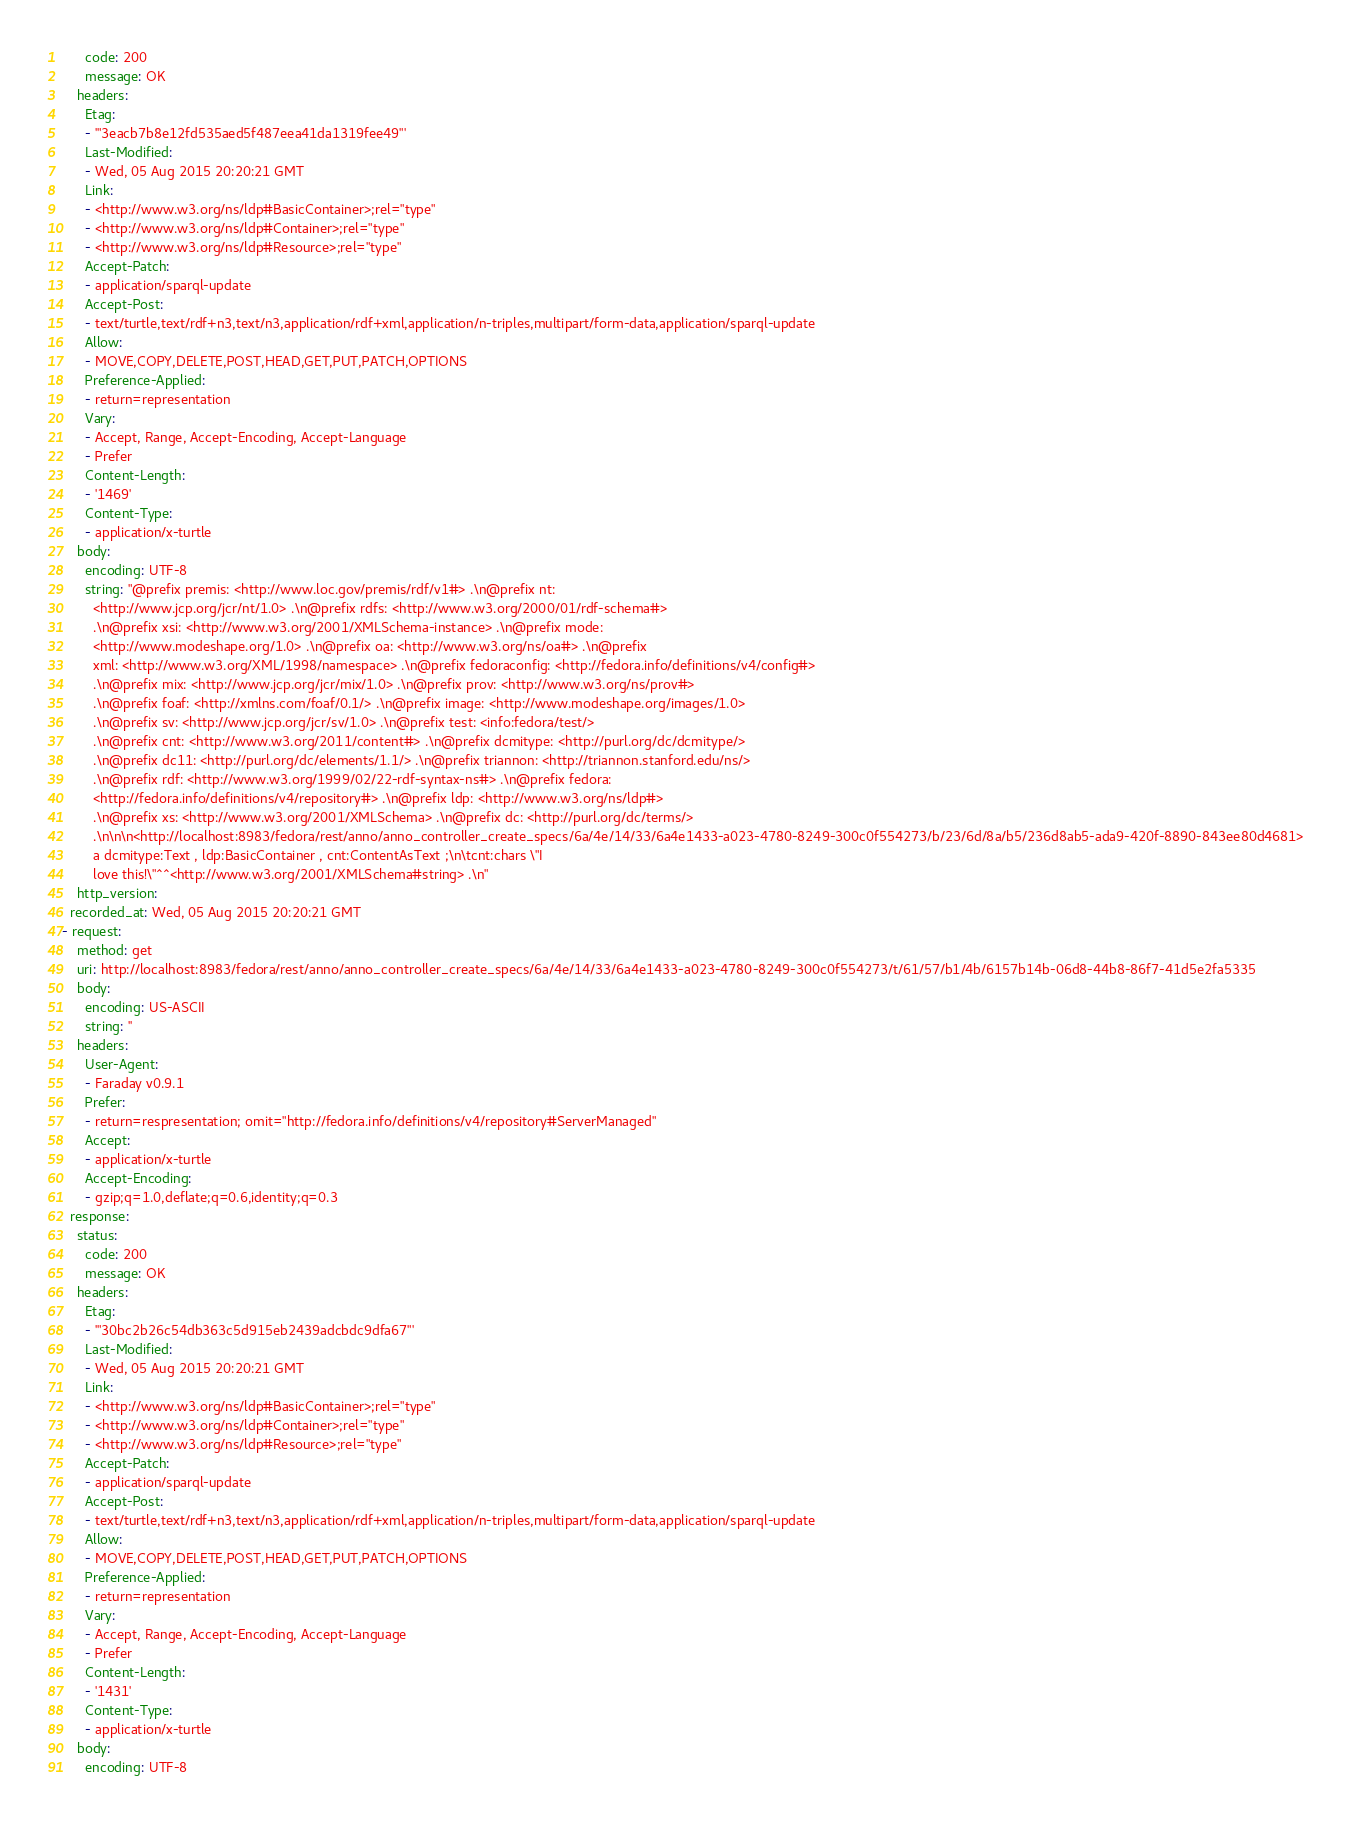Convert code to text. <code><loc_0><loc_0><loc_500><loc_500><_YAML_>      code: 200
      message: OK
    headers:
      Etag:
      - '"3eacb7b8e12fd535aed5f487eea41da1319fee49"'
      Last-Modified:
      - Wed, 05 Aug 2015 20:20:21 GMT
      Link:
      - <http://www.w3.org/ns/ldp#BasicContainer>;rel="type"
      - <http://www.w3.org/ns/ldp#Container>;rel="type"
      - <http://www.w3.org/ns/ldp#Resource>;rel="type"
      Accept-Patch:
      - application/sparql-update
      Accept-Post:
      - text/turtle,text/rdf+n3,text/n3,application/rdf+xml,application/n-triples,multipart/form-data,application/sparql-update
      Allow:
      - MOVE,COPY,DELETE,POST,HEAD,GET,PUT,PATCH,OPTIONS
      Preference-Applied:
      - return=representation
      Vary:
      - Accept, Range, Accept-Encoding, Accept-Language
      - Prefer
      Content-Length:
      - '1469'
      Content-Type:
      - application/x-turtle
    body:
      encoding: UTF-8
      string: "@prefix premis: <http://www.loc.gov/premis/rdf/v1#> .\n@prefix nt:
        <http://www.jcp.org/jcr/nt/1.0> .\n@prefix rdfs: <http://www.w3.org/2000/01/rdf-schema#>
        .\n@prefix xsi: <http://www.w3.org/2001/XMLSchema-instance> .\n@prefix mode:
        <http://www.modeshape.org/1.0> .\n@prefix oa: <http://www.w3.org/ns/oa#> .\n@prefix
        xml: <http://www.w3.org/XML/1998/namespace> .\n@prefix fedoraconfig: <http://fedora.info/definitions/v4/config#>
        .\n@prefix mix: <http://www.jcp.org/jcr/mix/1.0> .\n@prefix prov: <http://www.w3.org/ns/prov#>
        .\n@prefix foaf: <http://xmlns.com/foaf/0.1/> .\n@prefix image: <http://www.modeshape.org/images/1.0>
        .\n@prefix sv: <http://www.jcp.org/jcr/sv/1.0> .\n@prefix test: <info:fedora/test/>
        .\n@prefix cnt: <http://www.w3.org/2011/content#> .\n@prefix dcmitype: <http://purl.org/dc/dcmitype/>
        .\n@prefix dc11: <http://purl.org/dc/elements/1.1/> .\n@prefix triannon: <http://triannon.stanford.edu/ns/>
        .\n@prefix rdf: <http://www.w3.org/1999/02/22-rdf-syntax-ns#> .\n@prefix fedora:
        <http://fedora.info/definitions/v4/repository#> .\n@prefix ldp: <http://www.w3.org/ns/ldp#>
        .\n@prefix xs: <http://www.w3.org/2001/XMLSchema> .\n@prefix dc: <http://purl.org/dc/terms/>
        .\n\n\n<http://localhost:8983/fedora/rest/anno/anno_controller_create_specs/6a/4e/14/33/6a4e1433-a023-4780-8249-300c0f554273/b/23/6d/8a/b5/236d8ab5-ada9-420f-8890-843ee80d4681>
        a dcmitype:Text , ldp:BasicContainer , cnt:ContentAsText ;\n\tcnt:chars \"I
        love this!\"^^<http://www.w3.org/2001/XMLSchema#string> .\n"
    http_version: 
  recorded_at: Wed, 05 Aug 2015 20:20:21 GMT
- request:
    method: get
    uri: http://localhost:8983/fedora/rest/anno/anno_controller_create_specs/6a/4e/14/33/6a4e1433-a023-4780-8249-300c0f554273/t/61/57/b1/4b/6157b14b-06d8-44b8-86f7-41d5e2fa5335
    body:
      encoding: US-ASCII
      string: ''
    headers:
      User-Agent:
      - Faraday v0.9.1
      Prefer:
      - return=respresentation; omit="http://fedora.info/definitions/v4/repository#ServerManaged"
      Accept:
      - application/x-turtle
      Accept-Encoding:
      - gzip;q=1.0,deflate;q=0.6,identity;q=0.3
  response:
    status:
      code: 200
      message: OK
    headers:
      Etag:
      - '"30bc2b26c54db363c5d915eb2439adcbdc9dfa67"'
      Last-Modified:
      - Wed, 05 Aug 2015 20:20:21 GMT
      Link:
      - <http://www.w3.org/ns/ldp#BasicContainer>;rel="type"
      - <http://www.w3.org/ns/ldp#Container>;rel="type"
      - <http://www.w3.org/ns/ldp#Resource>;rel="type"
      Accept-Patch:
      - application/sparql-update
      Accept-Post:
      - text/turtle,text/rdf+n3,text/n3,application/rdf+xml,application/n-triples,multipart/form-data,application/sparql-update
      Allow:
      - MOVE,COPY,DELETE,POST,HEAD,GET,PUT,PATCH,OPTIONS
      Preference-Applied:
      - return=representation
      Vary:
      - Accept, Range, Accept-Encoding, Accept-Language
      - Prefer
      Content-Length:
      - '1431'
      Content-Type:
      - application/x-turtle
    body:
      encoding: UTF-8</code> 